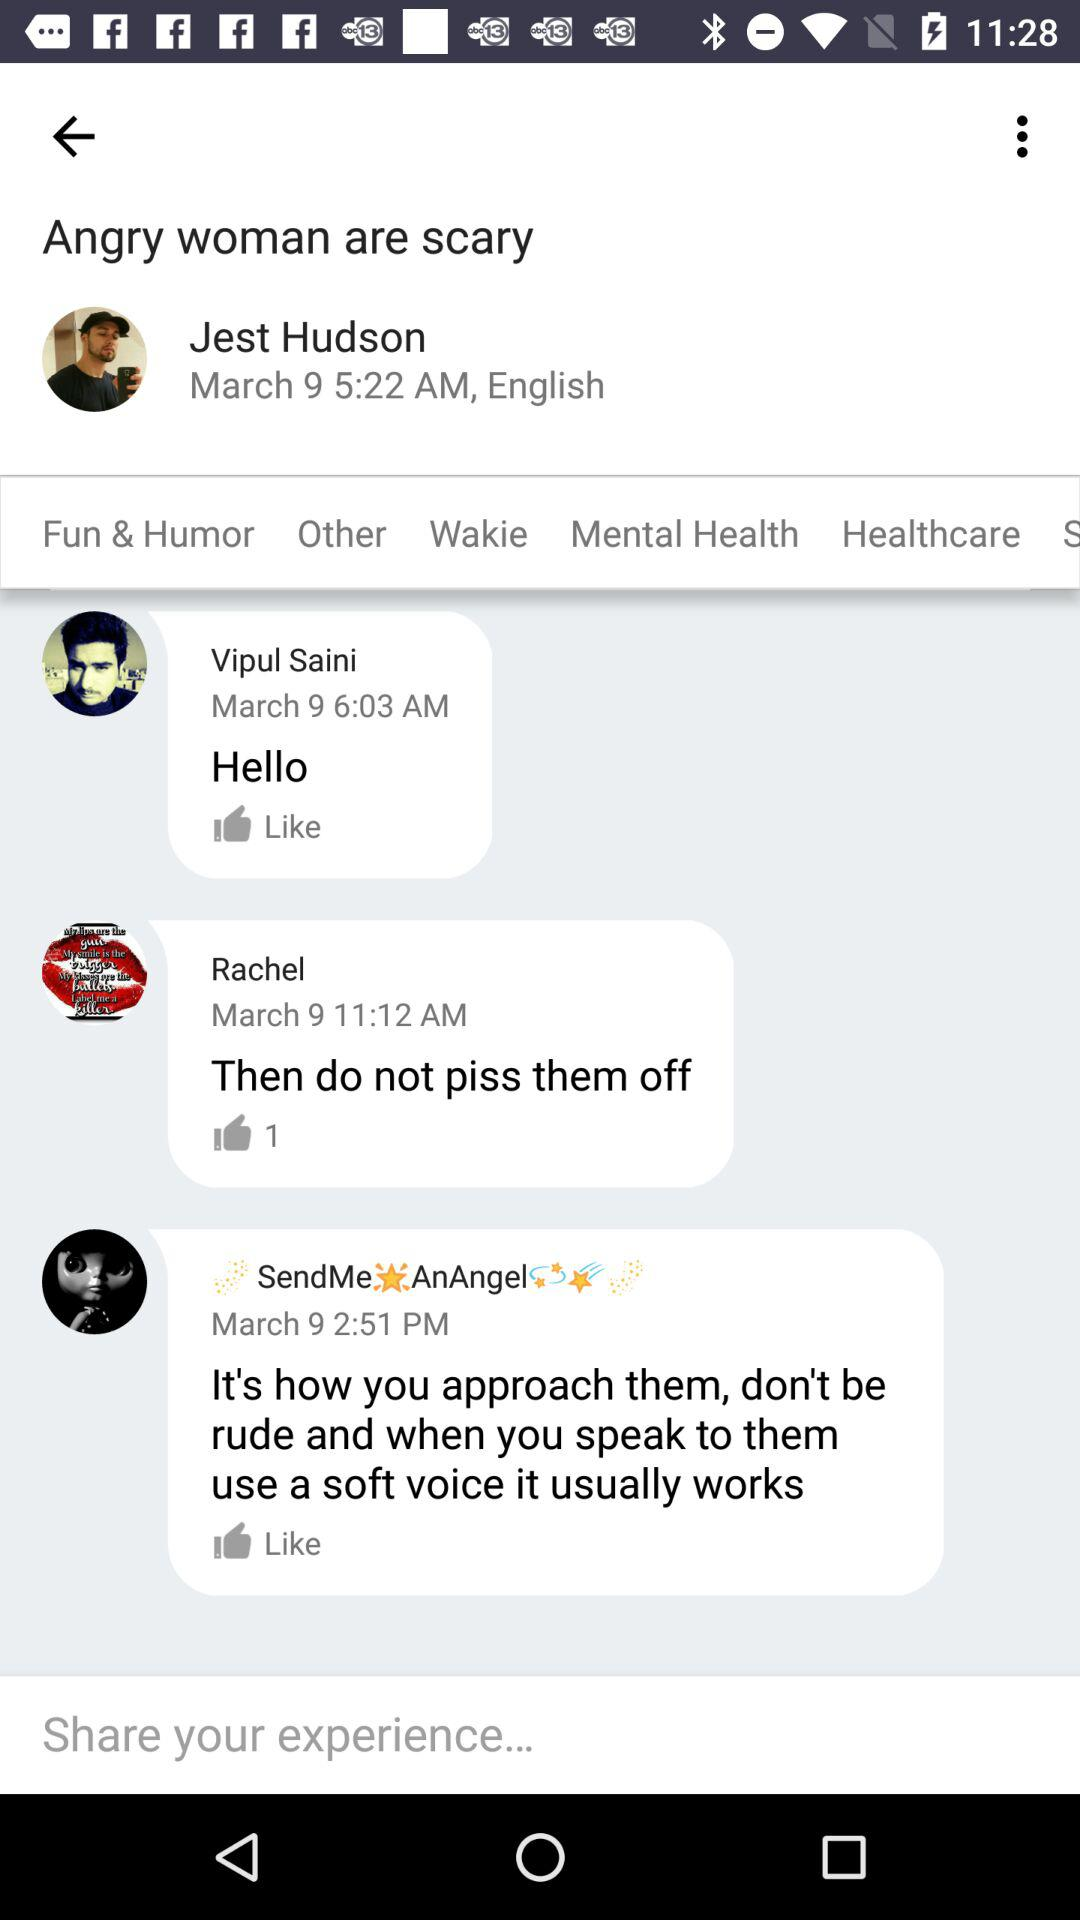How many user found online?
When the provided information is insufficient, respond with <no answer>. <no answer> 